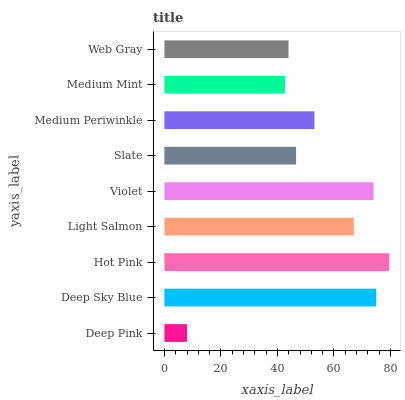Is Deep Pink the minimum?
Answer yes or no. Yes. Is Hot Pink the maximum?
Answer yes or no. Yes. Is Deep Sky Blue the minimum?
Answer yes or no. No. Is Deep Sky Blue the maximum?
Answer yes or no. No. Is Deep Sky Blue greater than Deep Pink?
Answer yes or no. Yes. Is Deep Pink less than Deep Sky Blue?
Answer yes or no. Yes. Is Deep Pink greater than Deep Sky Blue?
Answer yes or no. No. Is Deep Sky Blue less than Deep Pink?
Answer yes or no. No. Is Medium Periwinkle the high median?
Answer yes or no. Yes. Is Medium Periwinkle the low median?
Answer yes or no. Yes. Is Violet the high median?
Answer yes or no. No. Is Deep Pink the low median?
Answer yes or no. No. 